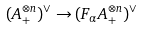Convert formula to latex. <formula><loc_0><loc_0><loc_500><loc_500>( A _ { + } ^ { \otimes n } ) ^ { \vee } \rightarrow ( F _ { \alpha } A _ { + } ^ { \otimes n } ) ^ { \vee }</formula> 